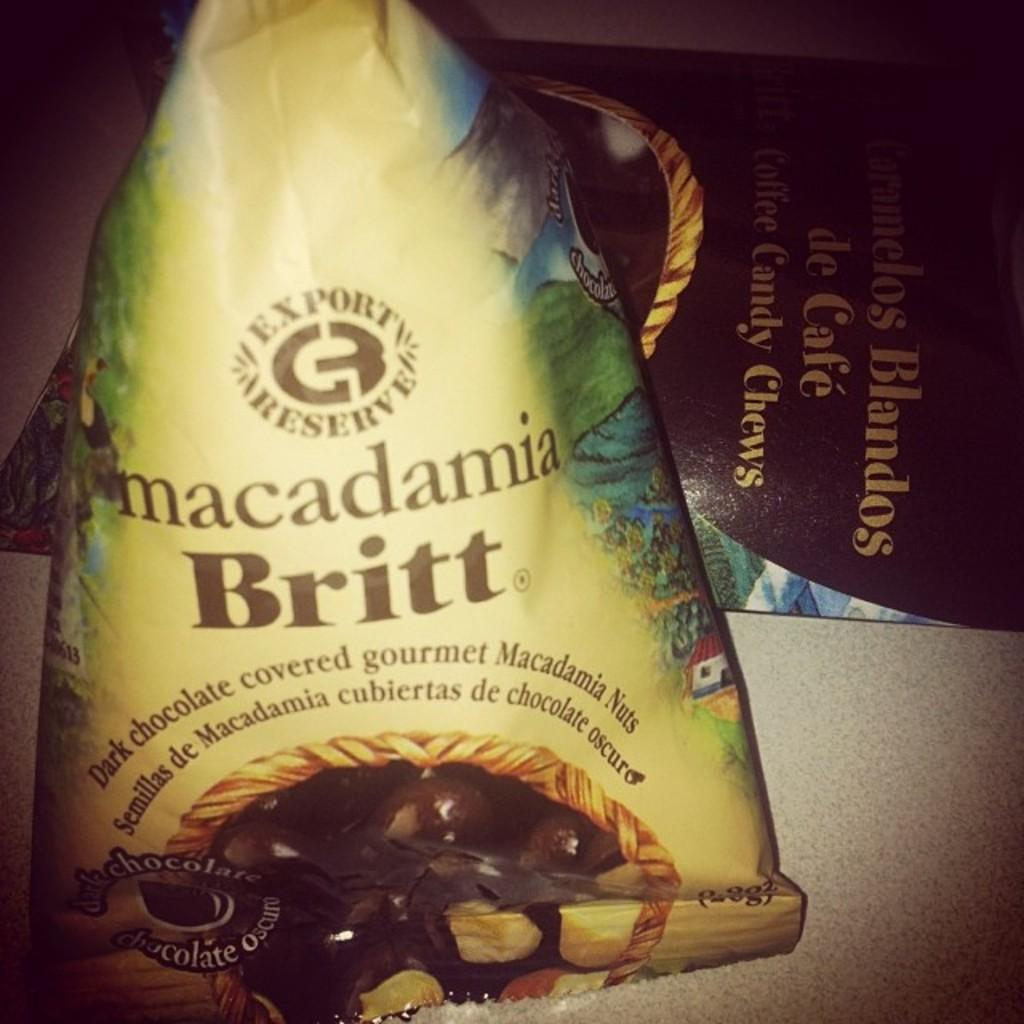<image>
Offer a succinct explanation of the picture presented. A bag of dark chocolate treats is labeled macadamia Britt. 